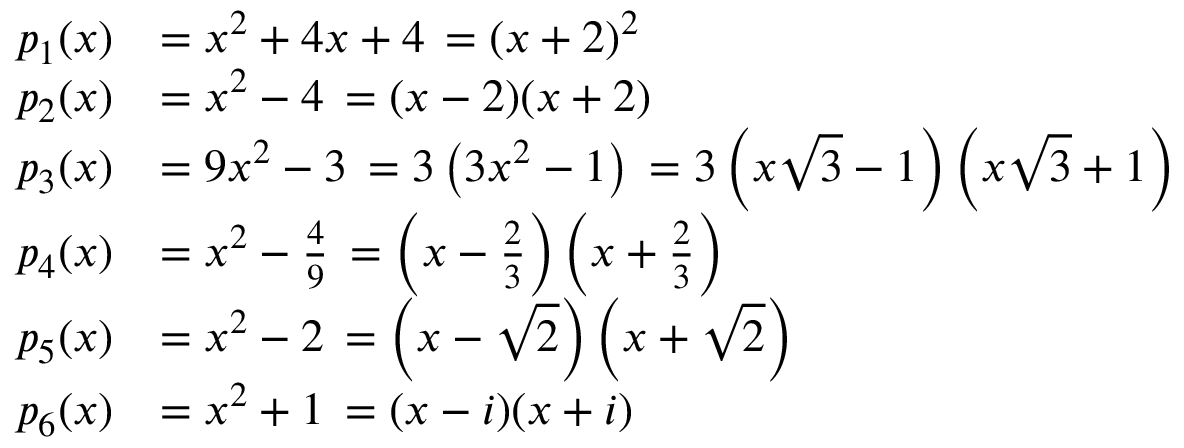Convert formula to latex. <formula><loc_0><loc_0><loc_500><loc_500>{ \begin{array} { r l } { p _ { 1 } ( x ) } & { = x ^ { 2 } + 4 x + 4 \, = { ( x + 2 ) ^ { 2 } } } \\ { p _ { 2 } ( x ) } & { = x ^ { 2 } - 4 \, = { ( x - 2 ) ( x + 2 ) } } \\ { p _ { 3 } ( x ) } & { = 9 x ^ { 2 } - 3 \, = 3 \left ( 3 x ^ { 2 } - 1 \right ) \, = 3 \left ( x { \sqrt { 3 } } - 1 \right ) \left ( x { \sqrt { 3 } } + 1 \right ) } \\ { p _ { 4 } ( x ) } & { = x ^ { 2 } - { \frac { 4 } { 9 } } \, = \left ( x - { \frac { 2 } { 3 } } \right ) \left ( x + { \frac { 2 } { 3 } } \right ) } \\ { p _ { 5 } ( x ) } & { = x ^ { 2 } - 2 \, = \left ( x - { \sqrt { 2 } } \right ) \left ( x + { \sqrt { 2 } } \right ) } \\ { p _ { 6 } ( x ) } & { = x ^ { 2 } + 1 \, = { ( x - i ) ( x + i ) } } \end{array} }</formula> 